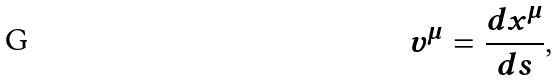<formula> <loc_0><loc_0><loc_500><loc_500>v ^ { \mu } = \frac { d x ^ { \mu } } { d s } ,</formula> 